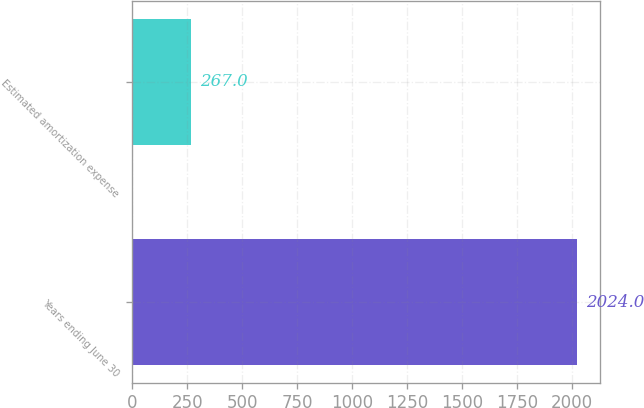Convert chart to OTSL. <chart><loc_0><loc_0><loc_500><loc_500><bar_chart><fcel>Years ending June 30<fcel>Estimated amortization expense<nl><fcel>2024<fcel>267<nl></chart> 